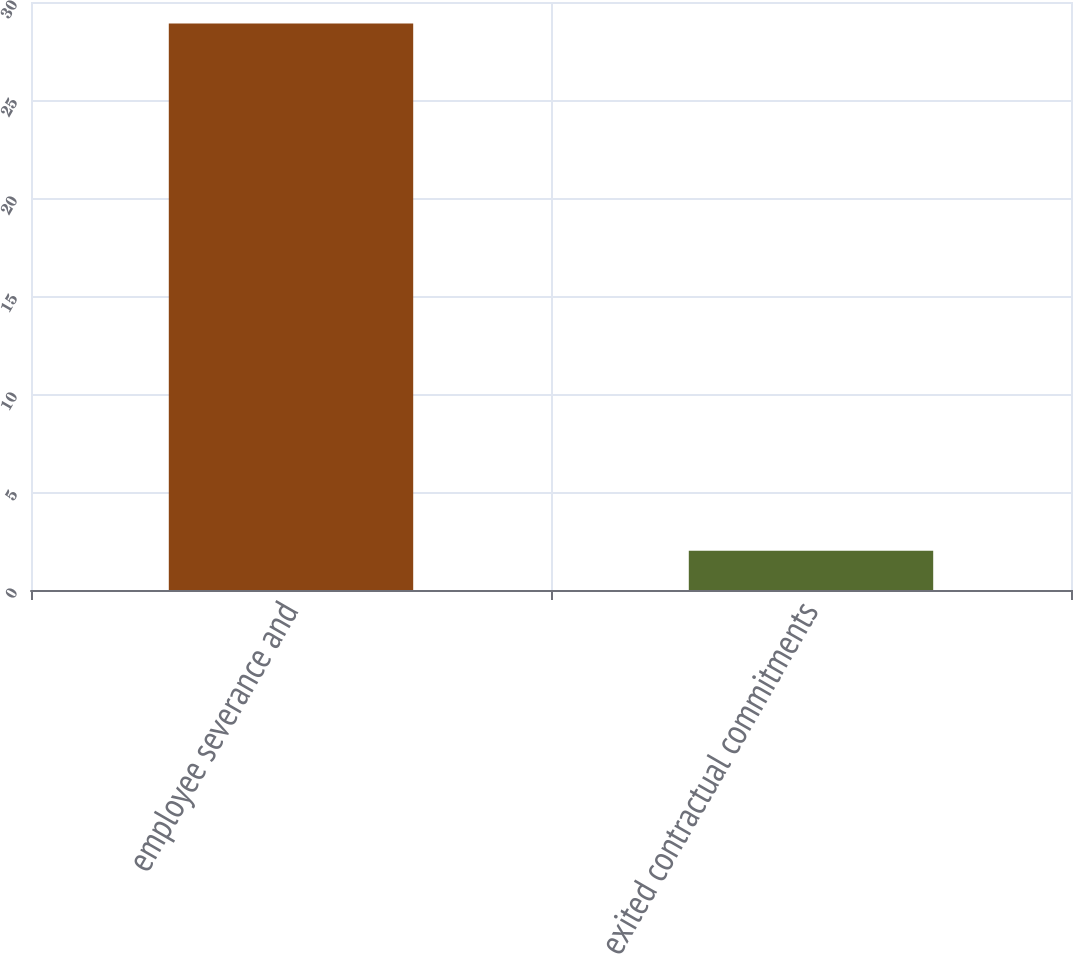Convert chart to OTSL. <chart><loc_0><loc_0><loc_500><loc_500><bar_chart><fcel>employee severance and<fcel>exited contractual commitments<nl><fcel>28.9<fcel>2<nl></chart> 